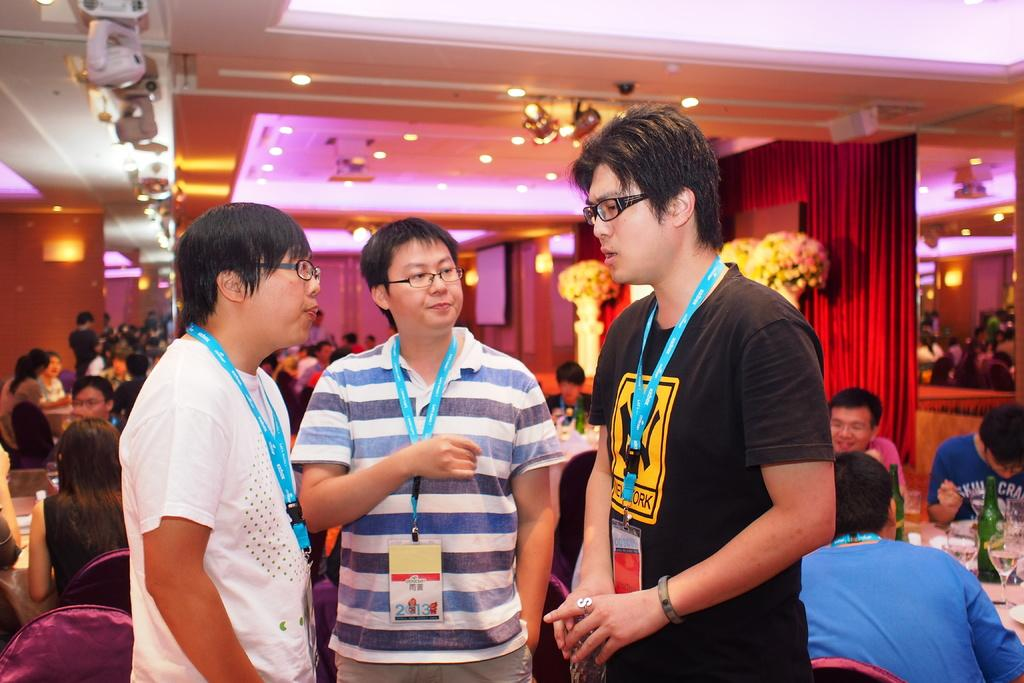How many people are present in the image? There are three people in the image. What are the people wearing that can be seen in the image? The people are wearing ID cards. What can be seen in the background of the image? There is a group of people, bottles, glasses, lights, a curtain, and some objects in the background of the image. What type of skin is visible on the cabbage in the image? There is no cabbage present in the image, so it is not possible to determine the type of skin visible on it. 